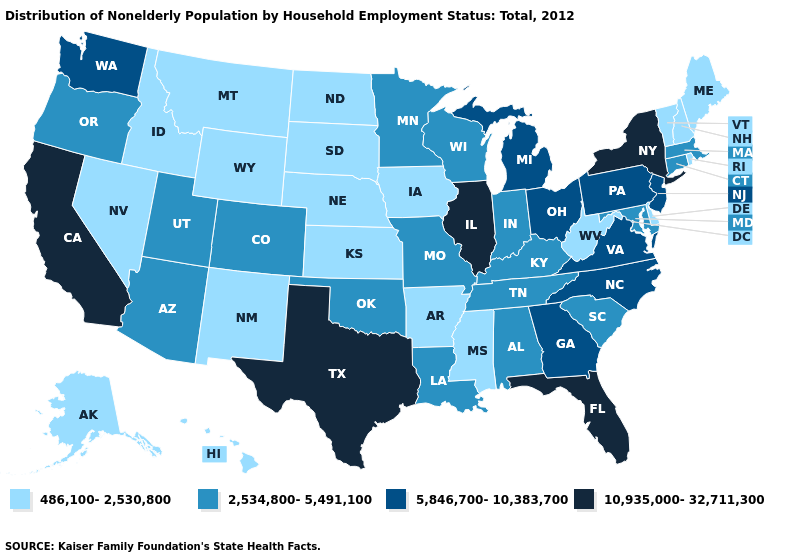What is the highest value in the USA?
Give a very brief answer. 10,935,000-32,711,300. What is the value of Idaho?
Concise answer only. 486,100-2,530,800. Name the states that have a value in the range 2,534,800-5,491,100?
Answer briefly. Alabama, Arizona, Colorado, Connecticut, Indiana, Kentucky, Louisiana, Maryland, Massachusetts, Minnesota, Missouri, Oklahoma, Oregon, South Carolina, Tennessee, Utah, Wisconsin. Name the states that have a value in the range 10,935,000-32,711,300?
Answer briefly. California, Florida, Illinois, New York, Texas. Name the states that have a value in the range 10,935,000-32,711,300?
Concise answer only. California, Florida, Illinois, New York, Texas. Among the states that border Texas , does Oklahoma have the highest value?
Concise answer only. Yes. Does Arkansas have a higher value than Iowa?
Quick response, please. No. Does Oregon have a higher value than Washington?
Quick response, please. No. Name the states that have a value in the range 486,100-2,530,800?
Concise answer only. Alaska, Arkansas, Delaware, Hawaii, Idaho, Iowa, Kansas, Maine, Mississippi, Montana, Nebraska, Nevada, New Hampshire, New Mexico, North Dakota, Rhode Island, South Dakota, Vermont, West Virginia, Wyoming. Name the states that have a value in the range 486,100-2,530,800?
Short answer required. Alaska, Arkansas, Delaware, Hawaii, Idaho, Iowa, Kansas, Maine, Mississippi, Montana, Nebraska, Nevada, New Hampshire, New Mexico, North Dakota, Rhode Island, South Dakota, Vermont, West Virginia, Wyoming. Name the states that have a value in the range 486,100-2,530,800?
Concise answer only. Alaska, Arkansas, Delaware, Hawaii, Idaho, Iowa, Kansas, Maine, Mississippi, Montana, Nebraska, Nevada, New Hampshire, New Mexico, North Dakota, Rhode Island, South Dakota, Vermont, West Virginia, Wyoming. What is the value of North Dakota?
Answer briefly. 486,100-2,530,800. Does the first symbol in the legend represent the smallest category?
Keep it brief. Yes. Name the states that have a value in the range 10,935,000-32,711,300?
Answer briefly. California, Florida, Illinois, New York, Texas. 